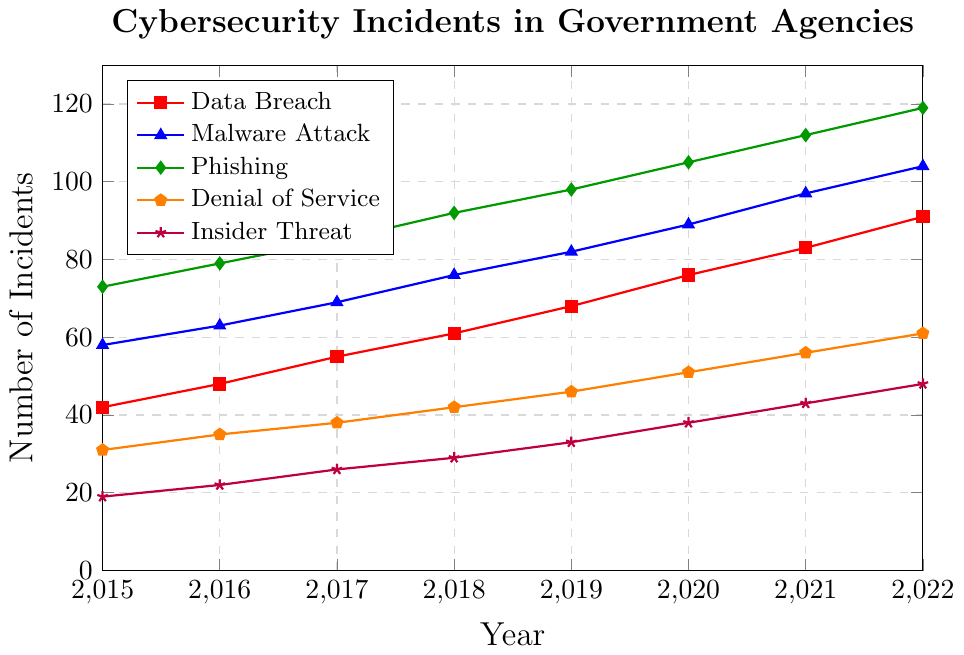What is the most frequent type of breach in 2022? By observing the line chart, identify the line that reaches the highest point in 2022. The line representing "Phishing" reaches 119 incidents, which is higher than any other type of breach that year.
Answer: Phishing How did the number of 'Insider Threat' incidents change from 2015 to 2022? Locate the points on the line chart for 'Insider Threat' corresponding to the years 2015 and 2022. The incidents increased from 19 in 2015 to 48 in 2022. The change is calculated as 48 - 19.
Answer: Increased by 29 Which type of breach had the smallest increase from 2015 to 2022? Calculate the difference between the 2015 and 2022 values for each line. 'Denial of Service' incidents grew from 31 to 61, an increase of 30. This is the smallest increase compared to other breach types.
Answer: Denial of Service In which year did 'Malware Attack' incidents surpass 90 for the first time? Follow the line for 'Malware Attack' and identify the year when the incidents first exceed 90. This occurs in 2020 when the value reaches 89 and continues to rise to 97 in 2021.
Answer: 2021 What is the combined total of all types of breaches in 2020? For each breach type, find the data point for the year 2020. Sum these values: Data Breach (76), Malware Attack (89), Phishing (105), Denial of Service (51), Insider Threat (38). The total is 76 + 89 + 105 + 51 + 38.
Answer: 359 Which year showed the largest increase in 'Phishing' incidents compared to the previous year? Calculate the yearly change for 'Phishing' incidents from 2015 to 2022. The largest increase is between 2021 (112) and 2022 (119), an increase of 7 incidents.
Answer: 2022 Compare the total number of 'Data Breach' and 'Denial of Service' incidents in 2019. Which one is higher? Find the values for 'Data Breach' and 'Denial of Service' in 2019. 'Data Breach' incidents are 68, and 'Denial of Service' incidents are 46. 68 is greater than 46.
Answer: Data Breach 